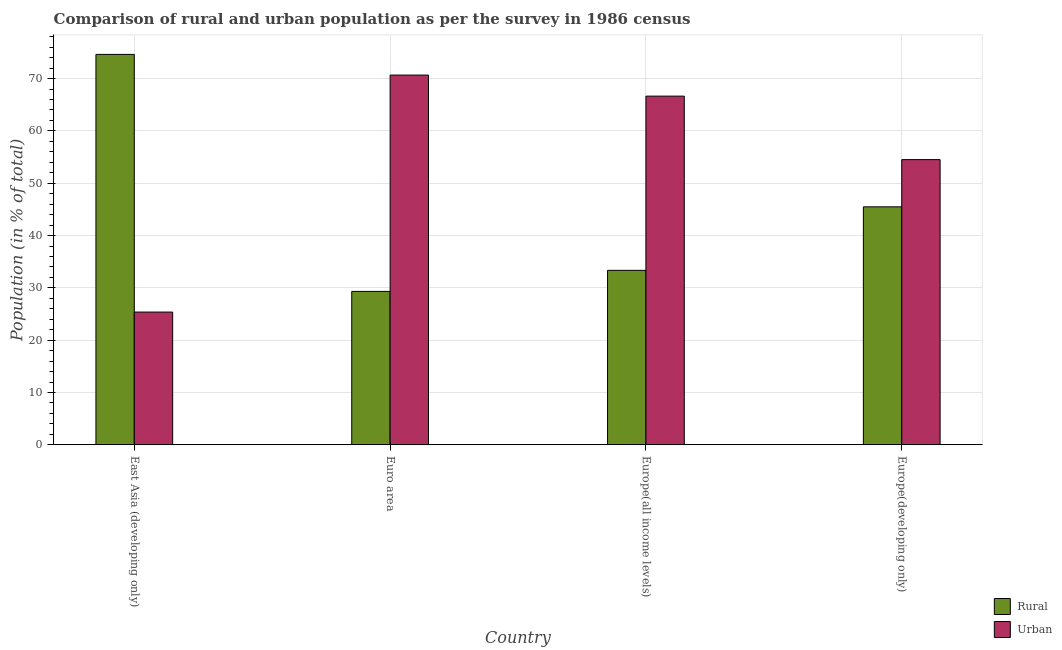How many different coloured bars are there?
Ensure brevity in your answer.  2. Are the number of bars per tick equal to the number of legend labels?
Offer a very short reply. Yes. Are the number of bars on each tick of the X-axis equal?
Provide a short and direct response. Yes. How many bars are there on the 3rd tick from the left?
Offer a terse response. 2. How many bars are there on the 4th tick from the right?
Ensure brevity in your answer.  2. In how many cases, is the number of bars for a given country not equal to the number of legend labels?
Provide a short and direct response. 0. What is the rural population in East Asia (developing only)?
Provide a succinct answer. 74.63. Across all countries, what is the maximum rural population?
Keep it short and to the point. 74.63. Across all countries, what is the minimum urban population?
Give a very brief answer. 25.37. In which country was the rural population maximum?
Your answer should be very brief. East Asia (developing only). In which country was the urban population minimum?
Offer a very short reply. East Asia (developing only). What is the total urban population in the graph?
Provide a short and direct response. 217.21. What is the difference between the rural population in Euro area and that in Europe(all income levels)?
Provide a succinct answer. -4.03. What is the difference between the urban population in Euro area and the rural population in East Asia (developing only)?
Make the answer very short. -3.95. What is the average rural population per country?
Offer a terse response. 45.7. What is the difference between the rural population and urban population in Europe(developing only)?
Offer a very short reply. -9.03. What is the ratio of the urban population in East Asia (developing only) to that in Europe(developing only)?
Offer a terse response. 0.47. What is the difference between the highest and the second highest urban population?
Your answer should be compact. 4.03. What is the difference between the highest and the lowest rural population?
Your answer should be very brief. 45.31. In how many countries, is the urban population greater than the average urban population taken over all countries?
Your answer should be compact. 3. What does the 1st bar from the left in East Asia (developing only) represents?
Keep it short and to the point. Rural. What does the 2nd bar from the right in Euro area represents?
Your answer should be very brief. Rural. How many bars are there?
Offer a terse response. 8. Are all the bars in the graph horizontal?
Make the answer very short. No. How many countries are there in the graph?
Ensure brevity in your answer.  4. What is the difference between two consecutive major ticks on the Y-axis?
Provide a succinct answer. 10. Are the values on the major ticks of Y-axis written in scientific E-notation?
Provide a succinct answer. No. Does the graph contain any zero values?
Make the answer very short. No. Does the graph contain grids?
Your answer should be very brief. Yes. Where does the legend appear in the graph?
Your answer should be compact. Bottom right. How many legend labels are there?
Ensure brevity in your answer.  2. What is the title of the graph?
Provide a short and direct response. Comparison of rural and urban population as per the survey in 1986 census. What is the label or title of the Y-axis?
Keep it short and to the point. Population (in % of total). What is the Population (in % of total) in Rural in East Asia (developing only)?
Provide a short and direct response. 74.63. What is the Population (in % of total) of Urban in East Asia (developing only)?
Offer a terse response. 25.37. What is the Population (in % of total) of Rural in Euro area?
Make the answer very short. 29.32. What is the Population (in % of total) in Urban in Euro area?
Provide a succinct answer. 70.68. What is the Population (in % of total) in Rural in Europe(all income levels)?
Your response must be concise. 33.35. What is the Population (in % of total) of Urban in Europe(all income levels)?
Offer a terse response. 66.65. What is the Population (in % of total) in Rural in Europe(developing only)?
Your answer should be very brief. 45.49. What is the Population (in % of total) in Urban in Europe(developing only)?
Provide a succinct answer. 54.51. Across all countries, what is the maximum Population (in % of total) in Rural?
Give a very brief answer. 74.63. Across all countries, what is the maximum Population (in % of total) of Urban?
Your answer should be compact. 70.68. Across all countries, what is the minimum Population (in % of total) of Rural?
Your answer should be compact. 29.32. Across all countries, what is the minimum Population (in % of total) of Urban?
Your answer should be compact. 25.37. What is the total Population (in % of total) of Rural in the graph?
Offer a very short reply. 182.79. What is the total Population (in % of total) of Urban in the graph?
Provide a short and direct response. 217.21. What is the difference between the Population (in % of total) in Rural in East Asia (developing only) and that in Euro area?
Give a very brief answer. 45.31. What is the difference between the Population (in % of total) of Urban in East Asia (developing only) and that in Euro area?
Ensure brevity in your answer.  -45.31. What is the difference between the Population (in % of total) in Rural in East Asia (developing only) and that in Europe(all income levels)?
Provide a succinct answer. 41.28. What is the difference between the Population (in % of total) in Urban in East Asia (developing only) and that in Europe(all income levels)?
Provide a succinct answer. -41.28. What is the difference between the Population (in % of total) of Rural in East Asia (developing only) and that in Europe(developing only)?
Provide a short and direct response. 29.14. What is the difference between the Population (in % of total) in Urban in East Asia (developing only) and that in Europe(developing only)?
Give a very brief answer. -29.14. What is the difference between the Population (in % of total) in Rural in Euro area and that in Europe(all income levels)?
Offer a very short reply. -4.03. What is the difference between the Population (in % of total) in Urban in Euro area and that in Europe(all income levels)?
Keep it short and to the point. 4.03. What is the difference between the Population (in % of total) of Rural in Euro area and that in Europe(developing only)?
Offer a very short reply. -16.16. What is the difference between the Population (in % of total) in Urban in Euro area and that in Europe(developing only)?
Make the answer very short. 16.16. What is the difference between the Population (in % of total) in Rural in Europe(all income levels) and that in Europe(developing only)?
Offer a terse response. -12.14. What is the difference between the Population (in % of total) in Urban in Europe(all income levels) and that in Europe(developing only)?
Provide a succinct answer. 12.14. What is the difference between the Population (in % of total) in Rural in East Asia (developing only) and the Population (in % of total) in Urban in Euro area?
Keep it short and to the point. 3.95. What is the difference between the Population (in % of total) of Rural in East Asia (developing only) and the Population (in % of total) of Urban in Europe(all income levels)?
Make the answer very short. 7.98. What is the difference between the Population (in % of total) of Rural in East Asia (developing only) and the Population (in % of total) of Urban in Europe(developing only)?
Provide a short and direct response. 20.11. What is the difference between the Population (in % of total) of Rural in Euro area and the Population (in % of total) of Urban in Europe(all income levels)?
Your answer should be very brief. -37.33. What is the difference between the Population (in % of total) of Rural in Euro area and the Population (in % of total) of Urban in Europe(developing only)?
Your response must be concise. -25.19. What is the difference between the Population (in % of total) of Rural in Europe(all income levels) and the Population (in % of total) of Urban in Europe(developing only)?
Your answer should be very brief. -21.16. What is the average Population (in % of total) of Rural per country?
Provide a succinct answer. 45.7. What is the average Population (in % of total) of Urban per country?
Provide a succinct answer. 54.3. What is the difference between the Population (in % of total) in Rural and Population (in % of total) in Urban in East Asia (developing only)?
Make the answer very short. 49.26. What is the difference between the Population (in % of total) in Rural and Population (in % of total) in Urban in Euro area?
Keep it short and to the point. -41.35. What is the difference between the Population (in % of total) of Rural and Population (in % of total) of Urban in Europe(all income levels)?
Keep it short and to the point. -33.3. What is the difference between the Population (in % of total) in Rural and Population (in % of total) in Urban in Europe(developing only)?
Your answer should be very brief. -9.03. What is the ratio of the Population (in % of total) in Rural in East Asia (developing only) to that in Euro area?
Ensure brevity in your answer.  2.55. What is the ratio of the Population (in % of total) of Urban in East Asia (developing only) to that in Euro area?
Offer a terse response. 0.36. What is the ratio of the Population (in % of total) in Rural in East Asia (developing only) to that in Europe(all income levels)?
Provide a short and direct response. 2.24. What is the ratio of the Population (in % of total) of Urban in East Asia (developing only) to that in Europe(all income levels)?
Provide a succinct answer. 0.38. What is the ratio of the Population (in % of total) in Rural in East Asia (developing only) to that in Europe(developing only)?
Your response must be concise. 1.64. What is the ratio of the Population (in % of total) in Urban in East Asia (developing only) to that in Europe(developing only)?
Your answer should be compact. 0.47. What is the ratio of the Population (in % of total) of Rural in Euro area to that in Europe(all income levels)?
Offer a terse response. 0.88. What is the ratio of the Population (in % of total) of Urban in Euro area to that in Europe(all income levels)?
Give a very brief answer. 1.06. What is the ratio of the Population (in % of total) of Rural in Euro area to that in Europe(developing only)?
Give a very brief answer. 0.64. What is the ratio of the Population (in % of total) in Urban in Euro area to that in Europe(developing only)?
Provide a succinct answer. 1.3. What is the ratio of the Population (in % of total) in Rural in Europe(all income levels) to that in Europe(developing only)?
Offer a terse response. 0.73. What is the ratio of the Population (in % of total) in Urban in Europe(all income levels) to that in Europe(developing only)?
Your response must be concise. 1.22. What is the difference between the highest and the second highest Population (in % of total) in Rural?
Ensure brevity in your answer.  29.14. What is the difference between the highest and the second highest Population (in % of total) in Urban?
Provide a succinct answer. 4.03. What is the difference between the highest and the lowest Population (in % of total) of Rural?
Your answer should be very brief. 45.31. What is the difference between the highest and the lowest Population (in % of total) of Urban?
Make the answer very short. 45.31. 